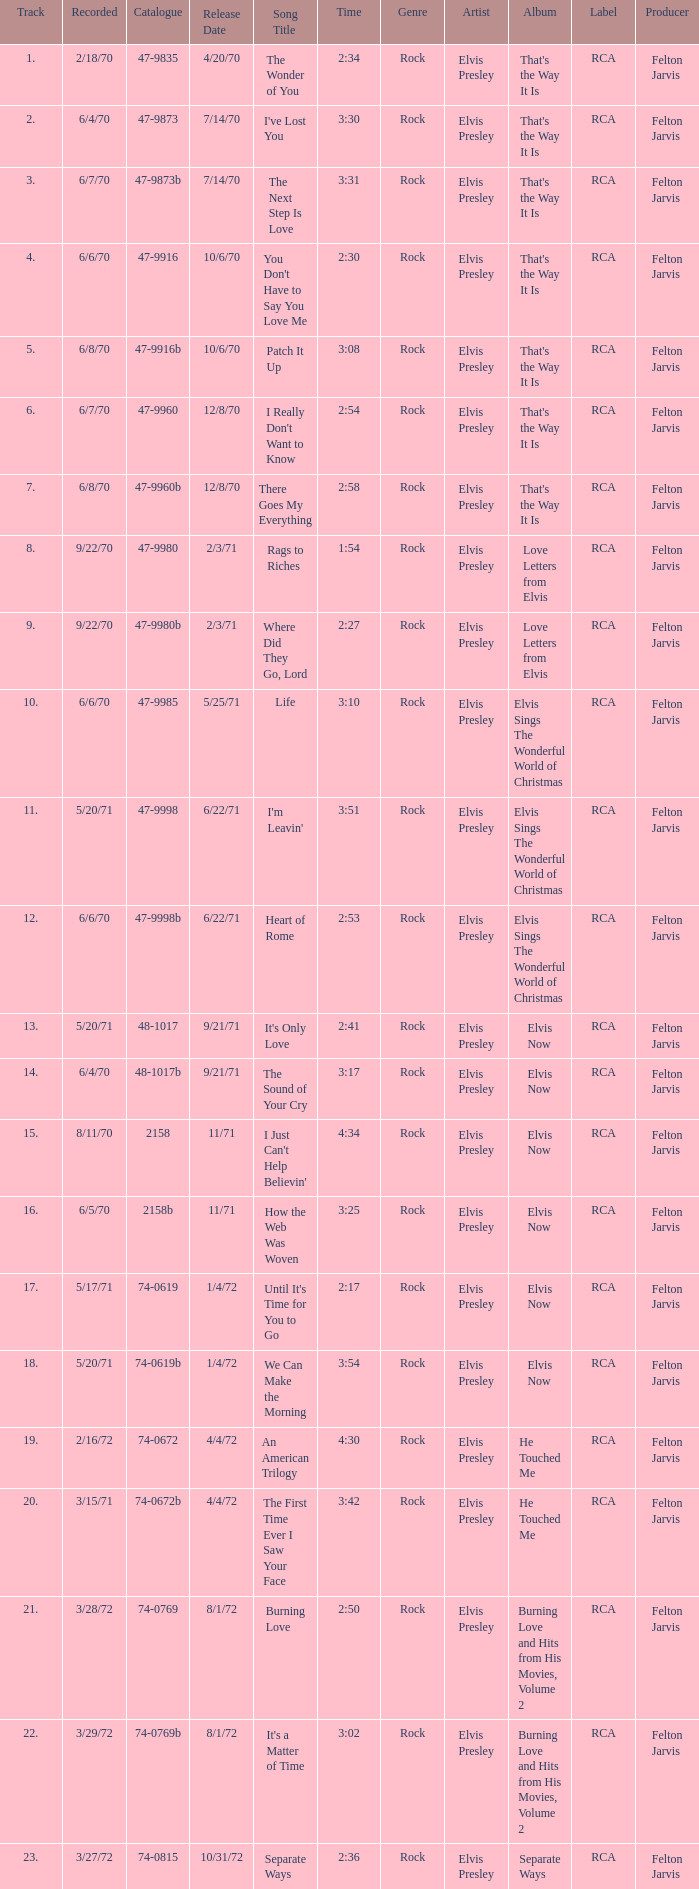What is Heart of Rome's catalogue number? 47-9998b. 